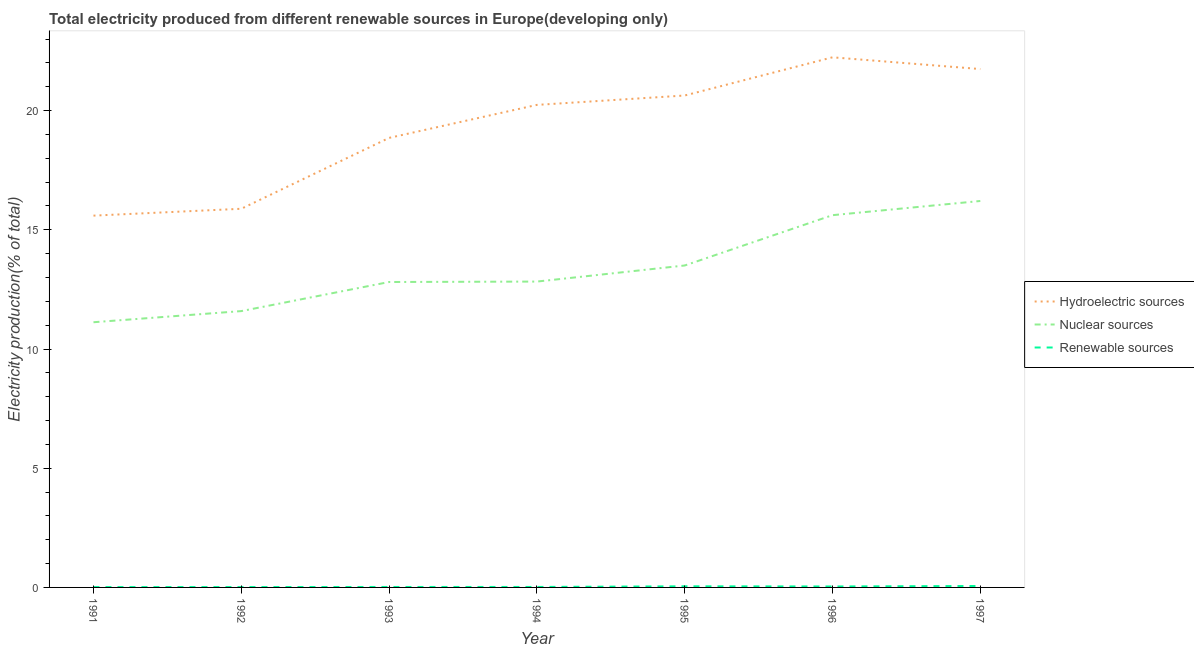What is the percentage of electricity produced by hydroelectric sources in 1994?
Your response must be concise. 20.24. Across all years, what is the maximum percentage of electricity produced by nuclear sources?
Your answer should be very brief. 16.21. Across all years, what is the minimum percentage of electricity produced by hydroelectric sources?
Your answer should be compact. 15.6. In which year was the percentage of electricity produced by hydroelectric sources minimum?
Provide a succinct answer. 1991. What is the total percentage of electricity produced by hydroelectric sources in the graph?
Your answer should be compact. 135.19. What is the difference between the percentage of electricity produced by renewable sources in 1993 and that in 1995?
Offer a very short reply. -0.03. What is the difference between the percentage of electricity produced by hydroelectric sources in 1991 and the percentage of electricity produced by nuclear sources in 1996?
Offer a terse response. -0.02. What is the average percentage of electricity produced by nuclear sources per year?
Keep it short and to the point. 13.38. In the year 1997, what is the difference between the percentage of electricity produced by renewable sources and percentage of electricity produced by nuclear sources?
Ensure brevity in your answer.  -16.15. In how many years, is the percentage of electricity produced by renewable sources greater than 5 %?
Make the answer very short. 0. What is the ratio of the percentage of electricity produced by hydroelectric sources in 1995 to that in 1997?
Keep it short and to the point. 0.95. Is the difference between the percentage of electricity produced by renewable sources in 1994 and 1995 greater than the difference between the percentage of electricity produced by hydroelectric sources in 1994 and 1995?
Provide a succinct answer. Yes. What is the difference between the highest and the second highest percentage of electricity produced by renewable sources?
Provide a succinct answer. 0.01. What is the difference between the highest and the lowest percentage of electricity produced by renewable sources?
Your answer should be very brief. 0.05. In how many years, is the percentage of electricity produced by hydroelectric sources greater than the average percentage of electricity produced by hydroelectric sources taken over all years?
Give a very brief answer. 4. Is the percentage of electricity produced by nuclear sources strictly less than the percentage of electricity produced by renewable sources over the years?
Provide a succinct answer. No. What is the difference between two consecutive major ticks on the Y-axis?
Provide a short and direct response. 5. Are the values on the major ticks of Y-axis written in scientific E-notation?
Offer a terse response. No. Does the graph contain grids?
Make the answer very short. No. How many legend labels are there?
Give a very brief answer. 3. How are the legend labels stacked?
Make the answer very short. Vertical. What is the title of the graph?
Offer a terse response. Total electricity produced from different renewable sources in Europe(developing only). Does "Injury" appear as one of the legend labels in the graph?
Make the answer very short. No. What is the label or title of the Y-axis?
Your answer should be very brief. Electricity production(% of total). What is the Electricity production(% of total) of Hydroelectric sources in 1991?
Make the answer very short. 15.6. What is the Electricity production(% of total) of Nuclear sources in 1991?
Ensure brevity in your answer.  11.12. What is the Electricity production(% of total) of Renewable sources in 1991?
Provide a succinct answer. 0.01. What is the Electricity production(% of total) of Hydroelectric sources in 1992?
Offer a very short reply. 15.88. What is the Electricity production(% of total) in Nuclear sources in 1992?
Provide a short and direct response. 11.59. What is the Electricity production(% of total) in Renewable sources in 1992?
Your response must be concise. 0.02. What is the Electricity production(% of total) in Hydroelectric sources in 1993?
Keep it short and to the point. 18.86. What is the Electricity production(% of total) in Nuclear sources in 1993?
Offer a very short reply. 12.81. What is the Electricity production(% of total) in Renewable sources in 1993?
Your response must be concise. 0.02. What is the Electricity production(% of total) in Hydroelectric sources in 1994?
Keep it short and to the point. 20.24. What is the Electricity production(% of total) in Nuclear sources in 1994?
Keep it short and to the point. 12.83. What is the Electricity production(% of total) of Renewable sources in 1994?
Your answer should be very brief. 0.02. What is the Electricity production(% of total) of Hydroelectric sources in 1995?
Your response must be concise. 20.63. What is the Electricity production(% of total) in Nuclear sources in 1995?
Give a very brief answer. 13.5. What is the Electricity production(% of total) in Renewable sources in 1995?
Your answer should be compact. 0.05. What is the Electricity production(% of total) of Hydroelectric sources in 1996?
Your answer should be very brief. 22.24. What is the Electricity production(% of total) in Nuclear sources in 1996?
Make the answer very short. 15.61. What is the Electricity production(% of total) of Renewable sources in 1996?
Offer a terse response. 0.04. What is the Electricity production(% of total) of Hydroelectric sources in 1997?
Provide a succinct answer. 21.74. What is the Electricity production(% of total) in Nuclear sources in 1997?
Offer a terse response. 16.21. What is the Electricity production(% of total) of Renewable sources in 1997?
Your response must be concise. 0.06. Across all years, what is the maximum Electricity production(% of total) of Hydroelectric sources?
Provide a succinct answer. 22.24. Across all years, what is the maximum Electricity production(% of total) of Nuclear sources?
Make the answer very short. 16.21. Across all years, what is the maximum Electricity production(% of total) in Renewable sources?
Keep it short and to the point. 0.06. Across all years, what is the minimum Electricity production(% of total) of Hydroelectric sources?
Keep it short and to the point. 15.6. Across all years, what is the minimum Electricity production(% of total) of Nuclear sources?
Offer a very short reply. 11.12. Across all years, what is the minimum Electricity production(% of total) of Renewable sources?
Your answer should be compact. 0.01. What is the total Electricity production(% of total) of Hydroelectric sources in the graph?
Your answer should be compact. 135.19. What is the total Electricity production(% of total) in Nuclear sources in the graph?
Provide a short and direct response. 93.69. What is the total Electricity production(% of total) of Renewable sources in the graph?
Your answer should be compact. 0.22. What is the difference between the Electricity production(% of total) in Hydroelectric sources in 1991 and that in 1992?
Ensure brevity in your answer.  -0.29. What is the difference between the Electricity production(% of total) of Nuclear sources in 1991 and that in 1992?
Ensure brevity in your answer.  -0.47. What is the difference between the Electricity production(% of total) of Renewable sources in 1991 and that in 1992?
Provide a short and direct response. -0. What is the difference between the Electricity production(% of total) in Hydroelectric sources in 1991 and that in 1993?
Provide a short and direct response. -3.26. What is the difference between the Electricity production(% of total) in Nuclear sources in 1991 and that in 1993?
Your response must be concise. -1.69. What is the difference between the Electricity production(% of total) of Renewable sources in 1991 and that in 1993?
Make the answer very short. -0. What is the difference between the Electricity production(% of total) in Hydroelectric sources in 1991 and that in 1994?
Offer a very short reply. -4.64. What is the difference between the Electricity production(% of total) in Nuclear sources in 1991 and that in 1994?
Offer a very short reply. -1.71. What is the difference between the Electricity production(% of total) in Renewable sources in 1991 and that in 1994?
Make the answer very short. -0. What is the difference between the Electricity production(% of total) of Hydroelectric sources in 1991 and that in 1995?
Offer a terse response. -5.04. What is the difference between the Electricity production(% of total) of Nuclear sources in 1991 and that in 1995?
Make the answer very short. -2.38. What is the difference between the Electricity production(% of total) in Renewable sources in 1991 and that in 1995?
Keep it short and to the point. -0.03. What is the difference between the Electricity production(% of total) of Hydroelectric sources in 1991 and that in 1996?
Your answer should be very brief. -6.64. What is the difference between the Electricity production(% of total) in Nuclear sources in 1991 and that in 1996?
Provide a short and direct response. -4.49. What is the difference between the Electricity production(% of total) in Renewable sources in 1991 and that in 1996?
Provide a short and direct response. -0.03. What is the difference between the Electricity production(% of total) in Hydroelectric sources in 1991 and that in 1997?
Your answer should be very brief. -6.15. What is the difference between the Electricity production(% of total) of Nuclear sources in 1991 and that in 1997?
Give a very brief answer. -5.09. What is the difference between the Electricity production(% of total) of Renewable sources in 1991 and that in 1997?
Your answer should be very brief. -0.05. What is the difference between the Electricity production(% of total) of Hydroelectric sources in 1992 and that in 1993?
Provide a succinct answer. -2.97. What is the difference between the Electricity production(% of total) of Nuclear sources in 1992 and that in 1993?
Provide a short and direct response. -1.22. What is the difference between the Electricity production(% of total) in Renewable sources in 1992 and that in 1993?
Make the answer very short. -0. What is the difference between the Electricity production(% of total) in Hydroelectric sources in 1992 and that in 1994?
Give a very brief answer. -4.36. What is the difference between the Electricity production(% of total) of Nuclear sources in 1992 and that in 1994?
Your answer should be very brief. -1.24. What is the difference between the Electricity production(% of total) in Renewable sources in 1992 and that in 1994?
Your answer should be very brief. -0. What is the difference between the Electricity production(% of total) of Hydroelectric sources in 1992 and that in 1995?
Keep it short and to the point. -4.75. What is the difference between the Electricity production(% of total) of Nuclear sources in 1992 and that in 1995?
Provide a succinct answer. -1.91. What is the difference between the Electricity production(% of total) in Renewable sources in 1992 and that in 1995?
Your response must be concise. -0.03. What is the difference between the Electricity production(% of total) of Hydroelectric sources in 1992 and that in 1996?
Your response must be concise. -6.35. What is the difference between the Electricity production(% of total) of Nuclear sources in 1992 and that in 1996?
Give a very brief answer. -4.02. What is the difference between the Electricity production(% of total) of Renewable sources in 1992 and that in 1996?
Ensure brevity in your answer.  -0.02. What is the difference between the Electricity production(% of total) in Hydroelectric sources in 1992 and that in 1997?
Ensure brevity in your answer.  -5.86. What is the difference between the Electricity production(% of total) of Nuclear sources in 1992 and that in 1997?
Keep it short and to the point. -4.62. What is the difference between the Electricity production(% of total) in Renewable sources in 1992 and that in 1997?
Provide a short and direct response. -0.04. What is the difference between the Electricity production(% of total) in Hydroelectric sources in 1993 and that in 1994?
Your response must be concise. -1.38. What is the difference between the Electricity production(% of total) in Nuclear sources in 1993 and that in 1994?
Keep it short and to the point. -0.02. What is the difference between the Electricity production(% of total) of Renewable sources in 1993 and that in 1994?
Your response must be concise. -0. What is the difference between the Electricity production(% of total) in Hydroelectric sources in 1993 and that in 1995?
Keep it short and to the point. -1.78. What is the difference between the Electricity production(% of total) of Nuclear sources in 1993 and that in 1995?
Make the answer very short. -0.69. What is the difference between the Electricity production(% of total) in Renewable sources in 1993 and that in 1995?
Give a very brief answer. -0.03. What is the difference between the Electricity production(% of total) in Hydroelectric sources in 1993 and that in 1996?
Offer a terse response. -3.38. What is the difference between the Electricity production(% of total) of Nuclear sources in 1993 and that in 1996?
Provide a short and direct response. -2.8. What is the difference between the Electricity production(% of total) of Renewable sources in 1993 and that in 1996?
Your response must be concise. -0.02. What is the difference between the Electricity production(% of total) of Hydroelectric sources in 1993 and that in 1997?
Give a very brief answer. -2.89. What is the difference between the Electricity production(% of total) of Nuclear sources in 1993 and that in 1997?
Provide a short and direct response. -3.4. What is the difference between the Electricity production(% of total) of Renewable sources in 1993 and that in 1997?
Give a very brief answer. -0.04. What is the difference between the Electricity production(% of total) of Hydroelectric sources in 1994 and that in 1995?
Offer a terse response. -0.39. What is the difference between the Electricity production(% of total) of Nuclear sources in 1994 and that in 1995?
Offer a very short reply. -0.67. What is the difference between the Electricity production(% of total) of Renewable sources in 1994 and that in 1995?
Ensure brevity in your answer.  -0.03. What is the difference between the Electricity production(% of total) of Hydroelectric sources in 1994 and that in 1996?
Your response must be concise. -2. What is the difference between the Electricity production(% of total) in Nuclear sources in 1994 and that in 1996?
Keep it short and to the point. -2.79. What is the difference between the Electricity production(% of total) in Renewable sources in 1994 and that in 1996?
Your answer should be compact. -0.02. What is the difference between the Electricity production(% of total) of Hydroelectric sources in 1994 and that in 1997?
Provide a succinct answer. -1.5. What is the difference between the Electricity production(% of total) of Nuclear sources in 1994 and that in 1997?
Keep it short and to the point. -3.38. What is the difference between the Electricity production(% of total) of Renewable sources in 1994 and that in 1997?
Provide a succinct answer. -0.04. What is the difference between the Electricity production(% of total) of Hydroelectric sources in 1995 and that in 1996?
Offer a terse response. -1.6. What is the difference between the Electricity production(% of total) of Nuclear sources in 1995 and that in 1996?
Offer a terse response. -2.11. What is the difference between the Electricity production(% of total) of Renewable sources in 1995 and that in 1996?
Your response must be concise. 0.01. What is the difference between the Electricity production(% of total) in Hydroelectric sources in 1995 and that in 1997?
Ensure brevity in your answer.  -1.11. What is the difference between the Electricity production(% of total) of Nuclear sources in 1995 and that in 1997?
Keep it short and to the point. -2.71. What is the difference between the Electricity production(% of total) in Renewable sources in 1995 and that in 1997?
Your response must be concise. -0.01. What is the difference between the Electricity production(% of total) in Hydroelectric sources in 1996 and that in 1997?
Offer a terse response. 0.49. What is the difference between the Electricity production(% of total) in Nuclear sources in 1996 and that in 1997?
Provide a short and direct response. -0.59. What is the difference between the Electricity production(% of total) of Renewable sources in 1996 and that in 1997?
Provide a short and direct response. -0.02. What is the difference between the Electricity production(% of total) of Hydroelectric sources in 1991 and the Electricity production(% of total) of Nuclear sources in 1992?
Your answer should be very brief. 4. What is the difference between the Electricity production(% of total) in Hydroelectric sources in 1991 and the Electricity production(% of total) in Renewable sources in 1992?
Your answer should be compact. 15.58. What is the difference between the Electricity production(% of total) in Nuclear sources in 1991 and the Electricity production(% of total) in Renewable sources in 1992?
Keep it short and to the point. 11.11. What is the difference between the Electricity production(% of total) in Hydroelectric sources in 1991 and the Electricity production(% of total) in Nuclear sources in 1993?
Your answer should be compact. 2.78. What is the difference between the Electricity production(% of total) of Hydroelectric sources in 1991 and the Electricity production(% of total) of Renewable sources in 1993?
Offer a terse response. 15.58. What is the difference between the Electricity production(% of total) of Nuclear sources in 1991 and the Electricity production(% of total) of Renewable sources in 1993?
Offer a terse response. 11.1. What is the difference between the Electricity production(% of total) of Hydroelectric sources in 1991 and the Electricity production(% of total) of Nuclear sources in 1994?
Your response must be concise. 2.77. What is the difference between the Electricity production(% of total) of Hydroelectric sources in 1991 and the Electricity production(% of total) of Renewable sources in 1994?
Give a very brief answer. 15.58. What is the difference between the Electricity production(% of total) in Nuclear sources in 1991 and the Electricity production(% of total) in Renewable sources in 1994?
Your response must be concise. 11.1. What is the difference between the Electricity production(% of total) in Hydroelectric sources in 1991 and the Electricity production(% of total) in Nuclear sources in 1995?
Your response must be concise. 2.09. What is the difference between the Electricity production(% of total) in Hydroelectric sources in 1991 and the Electricity production(% of total) in Renewable sources in 1995?
Keep it short and to the point. 15.55. What is the difference between the Electricity production(% of total) of Nuclear sources in 1991 and the Electricity production(% of total) of Renewable sources in 1995?
Give a very brief answer. 11.08. What is the difference between the Electricity production(% of total) of Hydroelectric sources in 1991 and the Electricity production(% of total) of Nuclear sources in 1996?
Your answer should be very brief. -0.02. What is the difference between the Electricity production(% of total) in Hydroelectric sources in 1991 and the Electricity production(% of total) in Renewable sources in 1996?
Ensure brevity in your answer.  15.56. What is the difference between the Electricity production(% of total) in Nuclear sources in 1991 and the Electricity production(% of total) in Renewable sources in 1996?
Your response must be concise. 11.08. What is the difference between the Electricity production(% of total) in Hydroelectric sources in 1991 and the Electricity production(% of total) in Nuclear sources in 1997?
Provide a succinct answer. -0.61. What is the difference between the Electricity production(% of total) in Hydroelectric sources in 1991 and the Electricity production(% of total) in Renewable sources in 1997?
Make the answer very short. 15.54. What is the difference between the Electricity production(% of total) of Nuclear sources in 1991 and the Electricity production(% of total) of Renewable sources in 1997?
Provide a succinct answer. 11.06. What is the difference between the Electricity production(% of total) of Hydroelectric sources in 1992 and the Electricity production(% of total) of Nuclear sources in 1993?
Provide a succinct answer. 3.07. What is the difference between the Electricity production(% of total) of Hydroelectric sources in 1992 and the Electricity production(% of total) of Renewable sources in 1993?
Offer a terse response. 15.86. What is the difference between the Electricity production(% of total) of Nuclear sources in 1992 and the Electricity production(% of total) of Renewable sources in 1993?
Keep it short and to the point. 11.57. What is the difference between the Electricity production(% of total) in Hydroelectric sources in 1992 and the Electricity production(% of total) in Nuclear sources in 1994?
Give a very brief answer. 3.05. What is the difference between the Electricity production(% of total) of Hydroelectric sources in 1992 and the Electricity production(% of total) of Renewable sources in 1994?
Provide a succinct answer. 15.86. What is the difference between the Electricity production(% of total) of Nuclear sources in 1992 and the Electricity production(% of total) of Renewable sources in 1994?
Your answer should be very brief. 11.57. What is the difference between the Electricity production(% of total) of Hydroelectric sources in 1992 and the Electricity production(% of total) of Nuclear sources in 1995?
Your answer should be very brief. 2.38. What is the difference between the Electricity production(% of total) of Hydroelectric sources in 1992 and the Electricity production(% of total) of Renewable sources in 1995?
Make the answer very short. 15.84. What is the difference between the Electricity production(% of total) of Nuclear sources in 1992 and the Electricity production(% of total) of Renewable sources in 1995?
Your response must be concise. 11.54. What is the difference between the Electricity production(% of total) in Hydroelectric sources in 1992 and the Electricity production(% of total) in Nuclear sources in 1996?
Your answer should be very brief. 0.27. What is the difference between the Electricity production(% of total) in Hydroelectric sources in 1992 and the Electricity production(% of total) in Renewable sources in 1996?
Keep it short and to the point. 15.84. What is the difference between the Electricity production(% of total) of Nuclear sources in 1992 and the Electricity production(% of total) of Renewable sources in 1996?
Offer a very short reply. 11.55. What is the difference between the Electricity production(% of total) in Hydroelectric sources in 1992 and the Electricity production(% of total) in Nuclear sources in 1997?
Offer a terse response. -0.33. What is the difference between the Electricity production(% of total) in Hydroelectric sources in 1992 and the Electricity production(% of total) in Renewable sources in 1997?
Ensure brevity in your answer.  15.82. What is the difference between the Electricity production(% of total) in Nuclear sources in 1992 and the Electricity production(% of total) in Renewable sources in 1997?
Keep it short and to the point. 11.53. What is the difference between the Electricity production(% of total) in Hydroelectric sources in 1993 and the Electricity production(% of total) in Nuclear sources in 1994?
Your response must be concise. 6.03. What is the difference between the Electricity production(% of total) of Hydroelectric sources in 1993 and the Electricity production(% of total) of Renewable sources in 1994?
Give a very brief answer. 18.84. What is the difference between the Electricity production(% of total) of Nuclear sources in 1993 and the Electricity production(% of total) of Renewable sources in 1994?
Provide a succinct answer. 12.79. What is the difference between the Electricity production(% of total) of Hydroelectric sources in 1993 and the Electricity production(% of total) of Nuclear sources in 1995?
Offer a terse response. 5.35. What is the difference between the Electricity production(% of total) in Hydroelectric sources in 1993 and the Electricity production(% of total) in Renewable sources in 1995?
Your answer should be compact. 18.81. What is the difference between the Electricity production(% of total) in Nuclear sources in 1993 and the Electricity production(% of total) in Renewable sources in 1995?
Offer a very short reply. 12.76. What is the difference between the Electricity production(% of total) of Hydroelectric sources in 1993 and the Electricity production(% of total) of Nuclear sources in 1996?
Provide a short and direct response. 3.24. What is the difference between the Electricity production(% of total) in Hydroelectric sources in 1993 and the Electricity production(% of total) in Renewable sources in 1996?
Keep it short and to the point. 18.82. What is the difference between the Electricity production(% of total) in Nuclear sources in 1993 and the Electricity production(% of total) in Renewable sources in 1996?
Your response must be concise. 12.77. What is the difference between the Electricity production(% of total) of Hydroelectric sources in 1993 and the Electricity production(% of total) of Nuclear sources in 1997?
Offer a terse response. 2.65. What is the difference between the Electricity production(% of total) of Hydroelectric sources in 1993 and the Electricity production(% of total) of Renewable sources in 1997?
Offer a very short reply. 18.8. What is the difference between the Electricity production(% of total) of Nuclear sources in 1993 and the Electricity production(% of total) of Renewable sources in 1997?
Your answer should be compact. 12.75. What is the difference between the Electricity production(% of total) in Hydroelectric sources in 1994 and the Electricity production(% of total) in Nuclear sources in 1995?
Your response must be concise. 6.74. What is the difference between the Electricity production(% of total) in Hydroelectric sources in 1994 and the Electricity production(% of total) in Renewable sources in 1995?
Offer a very short reply. 20.19. What is the difference between the Electricity production(% of total) of Nuclear sources in 1994 and the Electricity production(% of total) of Renewable sources in 1995?
Give a very brief answer. 12.78. What is the difference between the Electricity production(% of total) of Hydroelectric sources in 1994 and the Electricity production(% of total) of Nuclear sources in 1996?
Keep it short and to the point. 4.63. What is the difference between the Electricity production(% of total) in Hydroelectric sources in 1994 and the Electricity production(% of total) in Renewable sources in 1996?
Provide a succinct answer. 20.2. What is the difference between the Electricity production(% of total) in Nuclear sources in 1994 and the Electricity production(% of total) in Renewable sources in 1996?
Offer a very short reply. 12.79. What is the difference between the Electricity production(% of total) of Hydroelectric sources in 1994 and the Electricity production(% of total) of Nuclear sources in 1997?
Your answer should be compact. 4.03. What is the difference between the Electricity production(% of total) in Hydroelectric sources in 1994 and the Electricity production(% of total) in Renewable sources in 1997?
Your answer should be compact. 20.18. What is the difference between the Electricity production(% of total) in Nuclear sources in 1994 and the Electricity production(% of total) in Renewable sources in 1997?
Offer a very short reply. 12.77. What is the difference between the Electricity production(% of total) in Hydroelectric sources in 1995 and the Electricity production(% of total) in Nuclear sources in 1996?
Provide a short and direct response. 5.02. What is the difference between the Electricity production(% of total) in Hydroelectric sources in 1995 and the Electricity production(% of total) in Renewable sources in 1996?
Ensure brevity in your answer.  20.59. What is the difference between the Electricity production(% of total) of Nuclear sources in 1995 and the Electricity production(% of total) of Renewable sources in 1996?
Make the answer very short. 13.46. What is the difference between the Electricity production(% of total) in Hydroelectric sources in 1995 and the Electricity production(% of total) in Nuclear sources in 1997?
Offer a terse response. 4.42. What is the difference between the Electricity production(% of total) of Hydroelectric sources in 1995 and the Electricity production(% of total) of Renewable sources in 1997?
Your answer should be very brief. 20.57. What is the difference between the Electricity production(% of total) in Nuclear sources in 1995 and the Electricity production(% of total) in Renewable sources in 1997?
Offer a very short reply. 13.44. What is the difference between the Electricity production(% of total) in Hydroelectric sources in 1996 and the Electricity production(% of total) in Nuclear sources in 1997?
Keep it short and to the point. 6.03. What is the difference between the Electricity production(% of total) of Hydroelectric sources in 1996 and the Electricity production(% of total) of Renewable sources in 1997?
Your answer should be compact. 22.18. What is the difference between the Electricity production(% of total) in Nuclear sources in 1996 and the Electricity production(% of total) in Renewable sources in 1997?
Give a very brief answer. 15.55. What is the average Electricity production(% of total) of Hydroelectric sources per year?
Offer a very short reply. 19.31. What is the average Electricity production(% of total) of Nuclear sources per year?
Provide a short and direct response. 13.38. What is the average Electricity production(% of total) in Renewable sources per year?
Offer a very short reply. 0.03. In the year 1991, what is the difference between the Electricity production(% of total) of Hydroelectric sources and Electricity production(% of total) of Nuclear sources?
Give a very brief answer. 4.47. In the year 1991, what is the difference between the Electricity production(% of total) of Hydroelectric sources and Electricity production(% of total) of Renewable sources?
Provide a short and direct response. 15.58. In the year 1991, what is the difference between the Electricity production(% of total) of Nuclear sources and Electricity production(% of total) of Renewable sources?
Make the answer very short. 11.11. In the year 1992, what is the difference between the Electricity production(% of total) in Hydroelectric sources and Electricity production(% of total) in Nuclear sources?
Ensure brevity in your answer.  4.29. In the year 1992, what is the difference between the Electricity production(% of total) in Hydroelectric sources and Electricity production(% of total) in Renewable sources?
Your response must be concise. 15.87. In the year 1992, what is the difference between the Electricity production(% of total) of Nuclear sources and Electricity production(% of total) of Renewable sources?
Provide a short and direct response. 11.58. In the year 1993, what is the difference between the Electricity production(% of total) in Hydroelectric sources and Electricity production(% of total) in Nuclear sources?
Your answer should be compact. 6.05. In the year 1993, what is the difference between the Electricity production(% of total) in Hydroelectric sources and Electricity production(% of total) in Renewable sources?
Provide a short and direct response. 18.84. In the year 1993, what is the difference between the Electricity production(% of total) in Nuclear sources and Electricity production(% of total) in Renewable sources?
Your response must be concise. 12.79. In the year 1994, what is the difference between the Electricity production(% of total) in Hydroelectric sources and Electricity production(% of total) in Nuclear sources?
Your answer should be very brief. 7.41. In the year 1994, what is the difference between the Electricity production(% of total) of Hydroelectric sources and Electricity production(% of total) of Renewable sources?
Your answer should be compact. 20.22. In the year 1994, what is the difference between the Electricity production(% of total) in Nuclear sources and Electricity production(% of total) in Renewable sources?
Offer a terse response. 12.81. In the year 1995, what is the difference between the Electricity production(% of total) in Hydroelectric sources and Electricity production(% of total) in Nuclear sources?
Your answer should be very brief. 7.13. In the year 1995, what is the difference between the Electricity production(% of total) of Hydroelectric sources and Electricity production(% of total) of Renewable sources?
Your response must be concise. 20.59. In the year 1995, what is the difference between the Electricity production(% of total) in Nuclear sources and Electricity production(% of total) in Renewable sources?
Your answer should be compact. 13.46. In the year 1996, what is the difference between the Electricity production(% of total) of Hydroelectric sources and Electricity production(% of total) of Nuclear sources?
Your response must be concise. 6.62. In the year 1996, what is the difference between the Electricity production(% of total) of Hydroelectric sources and Electricity production(% of total) of Renewable sources?
Your answer should be very brief. 22.2. In the year 1996, what is the difference between the Electricity production(% of total) of Nuclear sources and Electricity production(% of total) of Renewable sources?
Your answer should be compact. 15.57. In the year 1997, what is the difference between the Electricity production(% of total) of Hydroelectric sources and Electricity production(% of total) of Nuclear sources?
Your answer should be compact. 5.53. In the year 1997, what is the difference between the Electricity production(% of total) of Hydroelectric sources and Electricity production(% of total) of Renewable sources?
Offer a terse response. 21.68. In the year 1997, what is the difference between the Electricity production(% of total) in Nuclear sources and Electricity production(% of total) in Renewable sources?
Ensure brevity in your answer.  16.15. What is the ratio of the Electricity production(% of total) of Hydroelectric sources in 1991 to that in 1992?
Keep it short and to the point. 0.98. What is the ratio of the Electricity production(% of total) in Nuclear sources in 1991 to that in 1992?
Make the answer very short. 0.96. What is the ratio of the Electricity production(% of total) in Renewable sources in 1991 to that in 1992?
Ensure brevity in your answer.  0.93. What is the ratio of the Electricity production(% of total) of Hydroelectric sources in 1991 to that in 1993?
Provide a short and direct response. 0.83. What is the ratio of the Electricity production(% of total) of Nuclear sources in 1991 to that in 1993?
Provide a succinct answer. 0.87. What is the ratio of the Electricity production(% of total) in Renewable sources in 1991 to that in 1993?
Your answer should be very brief. 0.77. What is the ratio of the Electricity production(% of total) in Hydroelectric sources in 1991 to that in 1994?
Make the answer very short. 0.77. What is the ratio of the Electricity production(% of total) of Nuclear sources in 1991 to that in 1994?
Make the answer very short. 0.87. What is the ratio of the Electricity production(% of total) in Renewable sources in 1991 to that in 1994?
Provide a short and direct response. 0.76. What is the ratio of the Electricity production(% of total) in Hydroelectric sources in 1991 to that in 1995?
Your answer should be compact. 0.76. What is the ratio of the Electricity production(% of total) of Nuclear sources in 1991 to that in 1995?
Provide a succinct answer. 0.82. What is the ratio of the Electricity production(% of total) in Renewable sources in 1991 to that in 1995?
Give a very brief answer. 0.32. What is the ratio of the Electricity production(% of total) in Hydroelectric sources in 1991 to that in 1996?
Your answer should be compact. 0.7. What is the ratio of the Electricity production(% of total) of Nuclear sources in 1991 to that in 1996?
Provide a succinct answer. 0.71. What is the ratio of the Electricity production(% of total) in Renewable sources in 1991 to that in 1996?
Your answer should be very brief. 0.37. What is the ratio of the Electricity production(% of total) of Hydroelectric sources in 1991 to that in 1997?
Your answer should be very brief. 0.72. What is the ratio of the Electricity production(% of total) in Nuclear sources in 1991 to that in 1997?
Offer a terse response. 0.69. What is the ratio of the Electricity production(% of total) of Renewable sources in 1991 to that in 1997?
Provide a succinct answer. 0.25. What is the ratio of the Electricity production(% of total) in Hydroelectric sources in 1992 to that in 1993?
Provide a succinct answer. 0.84. What is the ratio of the Electricity production(% of total) of Nuclear sources in 1992 to that in 1993?
Ensure brevity in your answer.  0.9. What is the ratio of the Electricity production(% of total) in Renewable sources in 1992 to that in 1993?
Your answer should be very brief. 0.83. What is the ratio of the Electricity production(% of total) of Hydroelectric sources in 1992 to that in 1994?
Your answer should be very brief. 0.78. What is the ratio of the Electricity production(% of total) in Nuclear sources in 1992 to that in 1994?
Offer a terse response. 0.9. What is the ratio of the Electricity production(% of total) in Renewable sources in 1992 to that in 1994?
Provide a short and direct response. 0.82. What is the ratio of the Electricity production(% of total) of Hydroelectric sources in 1992 to that in 1995?
Provide a short and direct response. 0.77. What is the ratio of the Electricity production(% of total) in Nuclear sources in 1992 to that in 1995?
Offer a very short reply. 0.86. What is the ratio of the Electricity production(% of total) of Renewable sources in 1992 to that in 1995?
Offer a very short reply. 0.34. What is the ratio of the Electricity production(% of total) in Nuclear sources in 1992 to that in 1996?
Your answer should be compact. 0.74. What is the ratio of the Electricity production(% of total) of Renewable sources in 1992 to that in 1996?
Offer a very short reply. 0.4. What is the ratio of the Electricity production(% of total) in Hydroelectric sources in 1992 to that in 1997?
Ensure brevity in your answer.  0.73. What is the ratio of the Electricity production(% of total) of Nuclear sources in 1992 to that in 1997?
Keep it short and to the point. 0.72. What is the ratio of the Electricity production(% of total) in Renewable sources in 1992 to that in 1997?
Provide a succinct answer. 0.27. What is the ratio of the Electricity production(% of total) of Hydroelectric sources in 1993 to that in 1994?
Make the answer very short. 0.93. What is the ratio of the Electricity production(% of total) in Nuclear sources in 1993 to that in 1994?
Offer a very short reply. 1. What is the ratio of the Electricity production(% of total) in Renewable sources in 1993 to that in 1994?
Provide a short and direct response. 0.98. What is the ratio of the Electricity production(% of total) in Hydroelectric sources in 1993 to that in 1995?
Offer a very short reply. 0.91. What is the ratio of the Electricity production(% of total) of Nuclear sources in 1993 to that in 1995?
Offer a very short reply. 0.95. What is the ratio of the Electricity production(% of total) of Renewable sources in 1993 to that in 1995?
Provide a succinct answer. 0.41. What is the ratio of the Electricity production(% of total) in Hydroelectric sources in 1993 to that in 1996?
Ensure brevity in your answer.  0.85. What is the ratio of the Electricity production(% of total) of Nuclear sources in 1993 to that in 1996?
Your response must be concise. 0.82. What is the ratio of the Electricity production(% of total) in Renewable sources in 1993 to that in 1996?
Your response must be concise. 0.48. What is the ratio of the Electricity production(% of total) of Hydroelectric sources in 1993 to that in 1997?
Offer a very short reply. 0.87. What is the ratio of the Electricity production(% of total) in Nuclear sources in 1993 to that in 1997?
Offer a very short reply. 0.79. What is the ratio of the Electricity production(% of total) in Renewable sources in 1993 to that in 1997?
Your answer should be compact. 0.32. What is the ratio of the Electricity production(% of total) in Hydroelectric sources in 1994 to that in 1995?
Your answer should be very brief. 0.98. What is the ratio of the Electricity production(% of total) of Nuclear sources in 1994 to that in 1995?
Offer a very short reply. 0.95. What is the ratio of the Electricity production(% of total) of Renewable sources in 1994 to that in 1995?
Your response must be concise. 0.42. What is the ratio of the Electricity production(% of total) of Hydroelectric sources in 1994 to that in 1996?
Your answer should be compact. 0.91. What is the ratio of the Electricity production(% of total) in Nuclear sources in 1994 to that in 1996?
Offer a very short reply. 0.82. What is the ratio of the Electricity production(% of total) of Renewable sources in 1994 to that in 1996?
Your response must be concise. 0.49. What is the ratio of the Electricity production(% of total) of Hydroelectric sources in 1994 to that in 1997?
Offer a terse response. 0.93. What is the ratio of the Electricity production(% of total) in Nuclear sources in 1994 to that in 1997?
Ensure brevity in your answer.  0.79. What is the ratio of the Electricity production(% of total) of Renewable sources in 1994 to that in 1997?
Your answer should be compact. 0.33. What is the ratio of the Electricity production(% of total) in Hydroelectric sources in 1995 to that in 1996?
Provide a short and direct response. 0.93. What is the ratio of the Electricity production(% of total) in Nuclear sources in 1995 to that in 1996?
Provide a short and direct response. 0.86. What is the ratio of the Electricity production(% of total) of Renewable sources in 1995 to that in 1996?
Ensure brevity in your answer.  1.18. What is the ratio of the Electricity production(% of total) in Hydroelectric sources in 1995 to that in 1997?
Your answer should be compact. 0.95. What is the ratio of the Electricity production(% of total) of Nuclear sources in 1995 to that in 1997?
Provide a short and direct response. 0.83. What is the ratio of the Electricity production(% of total) in Renewable sources in 1995 to that in 1997?
Ensure brevity in your answer.  0.78. What is the ratio of the Electricity production(% of total) of Hydroelectric sources in 1996 to that in 1997?
Give a very brief answer. 1.02. What is the ratio of the Electricity production(% of total) of Nuclear sources in 1996 to that in 1997?
Your answer should be very brief. 0.96. What is the ratio of the Electricity production(% of total) of Renewable sources in 1996 to that in 1997?
Offer a very short reply. 0.66. What is the difference between the highest and the second highest Electricity production(% of total) of Hydroelectric sources?
Your answer should be compact. 0.49. What is the difference between the highest and the second highest Electricity production(% of total) of Nuclear sources?
Your answer should be compact. 0.59. What is the difference between the highest and the second highest Electricity production(% of total) of Renewable sources?
Your answer should be very brief. 0.01. What is the difference between the highest and the lowest Electricity production(% of total) of Hydroelectric sources?
Make the answer very short. 6.64. What is the difference between the highest and the lowest Electricity production(% of total) of Nuclear sources?
Provide a succinct answer. 5.09. What is the difference between the highest and the lowest Electricity production(% of total) in Renewable sources?
Provide a short and direct response. 0.05. 